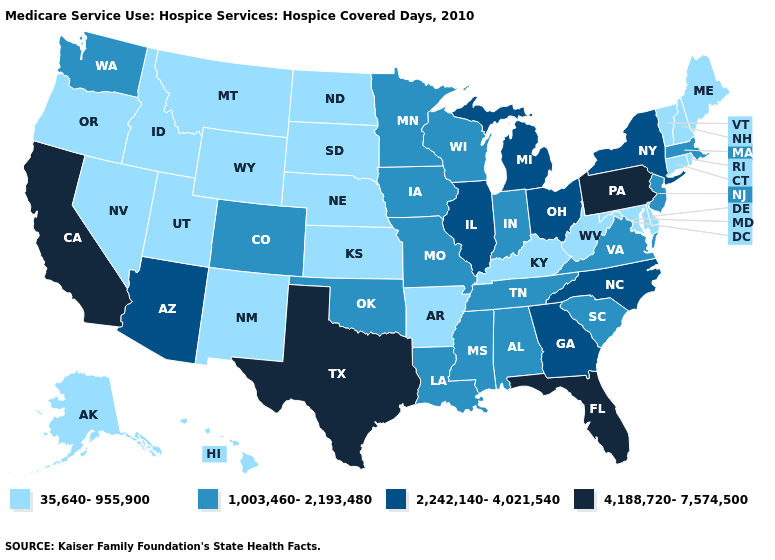How many symbols are there in the legend?
Be succinct. 4. Does Utah have the lowest value in the USA?
Keep it brief. Yes. Does Wisconsin have a lower value than Pennsylvania?
Write a very short answer. Yes. Name the states that have a value in the range 4,188,720-7,574,500?
Write a very short answer. California, Florida, Pennsylvania, Texas. Does Georgia have the lowest value in the South?
Quick response, please. No. What is the value of Wisconsin?
Quick response, please. 1,003,460-2,193,480. Among the states that border Kansas , does Missouri have the lowest value?
Give a very brief answer. No. What is the value of Kansas?
Quick response, please. 35,640-955,900. Is the legend a continuous bar?
Answer briefly. No. What is the value of Nevada?
Quick response, please. 35,640-955,900. What is the value of Idaho?
Short answer required. 35,640-955,900. What is the value of Maryland?
Concise answer only. 35,640-955,900. Name the states that have a value in the range 35,640-955,900?
Answer briefly. Alaska, Arkansas, Connecticut, Delaware, Hawaii, Idaho, Kansas, Kentucky, Maine, Maryland, Montana, Nebraska, Nevada, New Hampshire, New Mexico, North Dakota, Oregon, Rhode Island, South Dakota, Utah, Vermont, West Virginia, Wyoming. What is the highest value in the USA?
Write a very short answer. 4,188,720-7,574,500. What is the lowest value in the USA?
Short answer required. 35,640-955,900. 